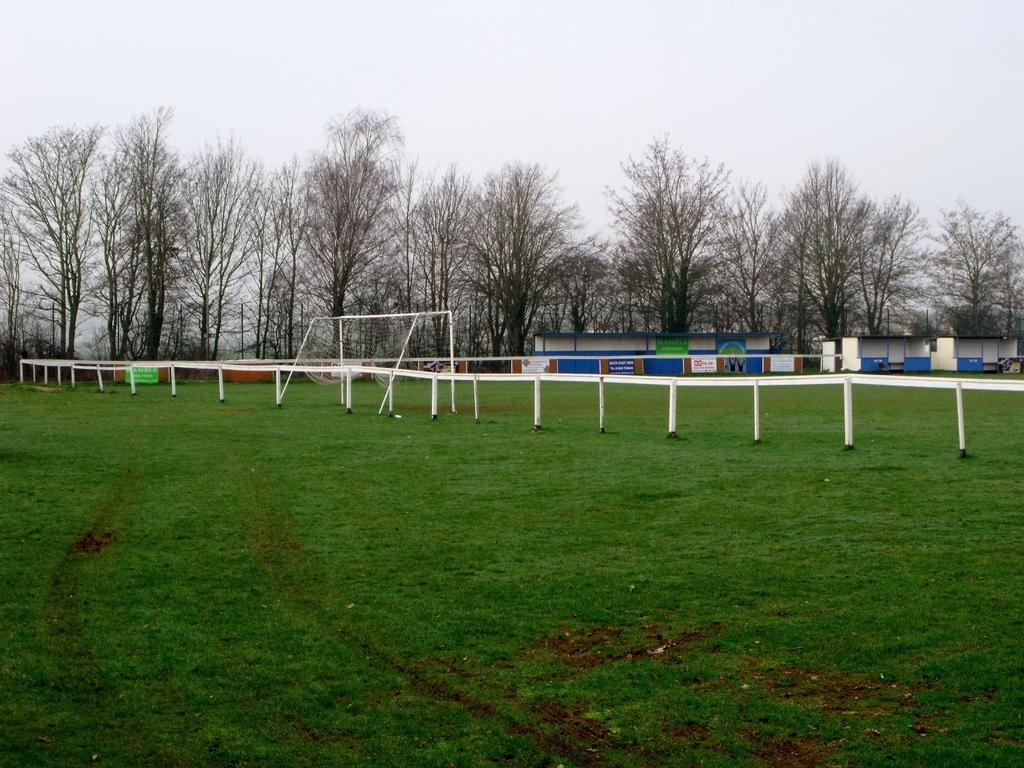What type of vegetation is present in the image? There is grass in the image. What objects can be seen in the image that are used for support or structure? There are rods in the image. What is used to catch or hold objects in the image? There is a net in the image. What decorative elements are present in the image? There are banners in the image. What type of shelter or storage can be seen in the image? There are sheds in the image. What type of natural elements are present in the image? There are trees in the image. What can be seen in the background of the image? The sky is visible in the background of the image. What emotion is displayed by the van in the image? There is no van present in the image, so it is not possible to determine any emotions displayed. What type of order is being followed in the image? The image does not depict any specific order or process, so it is not possible to determine any orders being followed. 